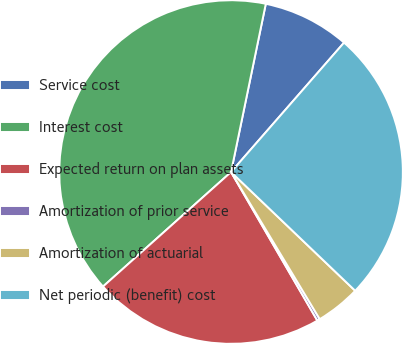<chart> <loc_0><loc_0><loc_500><loc_500><pie_chart><fcel>Service cost<fcel>Interest cost<fcel>Expected return on plan assets<fcel>Amortization of prior service<fcel>Amortization of actuarial<fcel>Net periodic (benefit) cost<nl><fcel>8.18%<fcel>39.85%<fcel>21.76%<fcel>0.26%<fcel>4.22%<fcel>25.72%<nl></chart> 